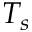Convert formula to latex. <formula><loc_0><loc_0><loc_500><loc_500>T _ { s }</formula> 